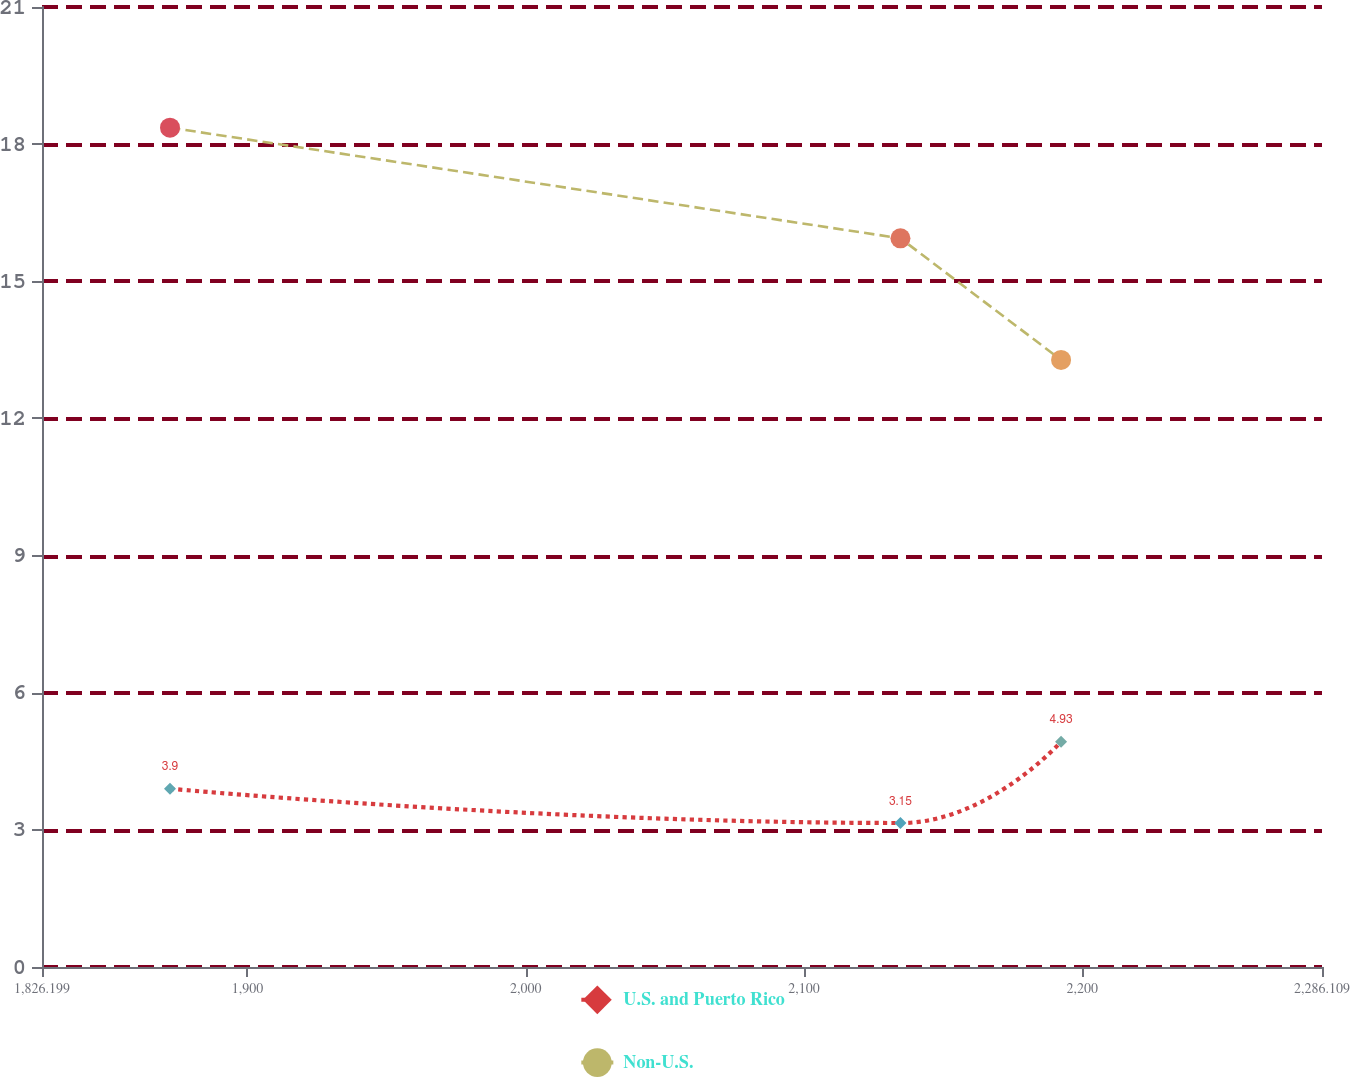<chart> <loc_0><loc_0><loc_500><loc_500><line_chart><ecel><fcel>U.S. and Puerto Rico<fcel>Non-U.S.<nl><fcel>1872.19<fcel>3.9<fcel>18.36<nl><fcel>2134.64<fcel>3.15<fcel>15.94<nl><fcel>2192.36<fcel>4.93<fcel>13.28<nl><fcel>2289.46<fcel>7.1<fcel>13.84<nl><fcel>2332.1<fcel>6.72<fcel>12.72<nl></chart> 